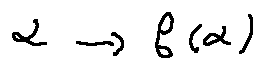Convert formula to latex. <formula><loc_0><loc_0><loc_500><loc_500>\alpha \rightarrow f ( \alpha )</formula> 